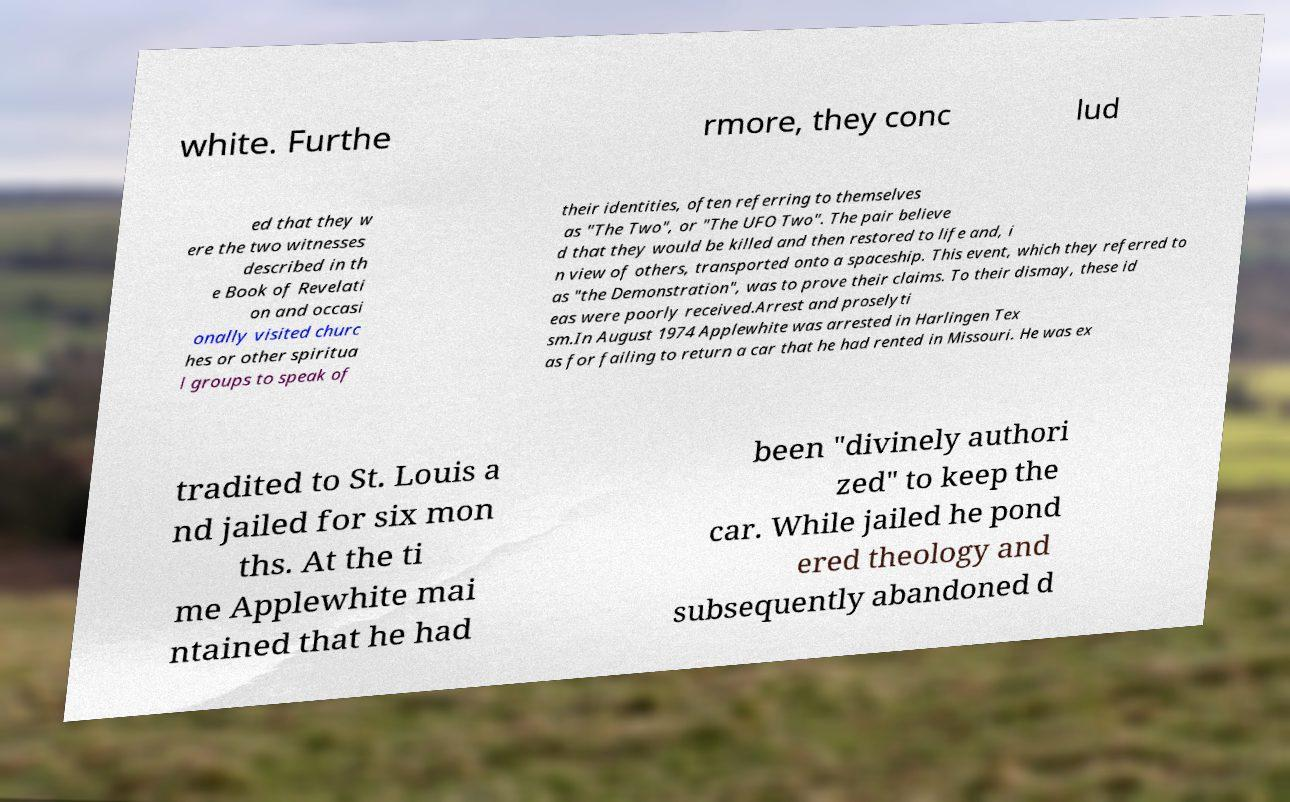For documentation purposes, I need the text within this image transcribed. Could you provide that? white. Furthe rmore, they conc lud ed that they w ere the two witnesses described in th e Book of Revelati on and occasi onally visited churc hes or other spiritua l groups to speak of their identities, often referring to themselves as "The Two", or "The UFO Two". The pair believe d that they would be killed and then restored to life and, i n view of others, transported onto a spaceship. This event, which they referred to as "the Demonstration", was to prove their claims. To their dismay, these id eas were poorly received.Arrest and proselyti sm.In August 1974 Applewhite was arrested in Harlingen Tex as for failing to return a car that he had rented in Missouri. He was ex tradited to St. Louis a nd jailed for six mon ths. At the ti me Applewhite mai ntained that he had been "divinely authori zed" to keep the car. While jailed he pond ered theology and subsequently abandoned d 